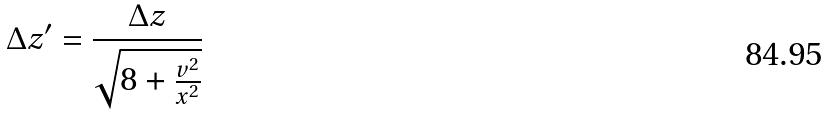<formula> <loc_0><loc_0><loc_500><loc_500>\Delta z ^ { \prime } = \frac { \Delta z } { \sqrt { 8 + \frac { v ^ { 2 } } { x ^ { 2 } } } }</formula> 